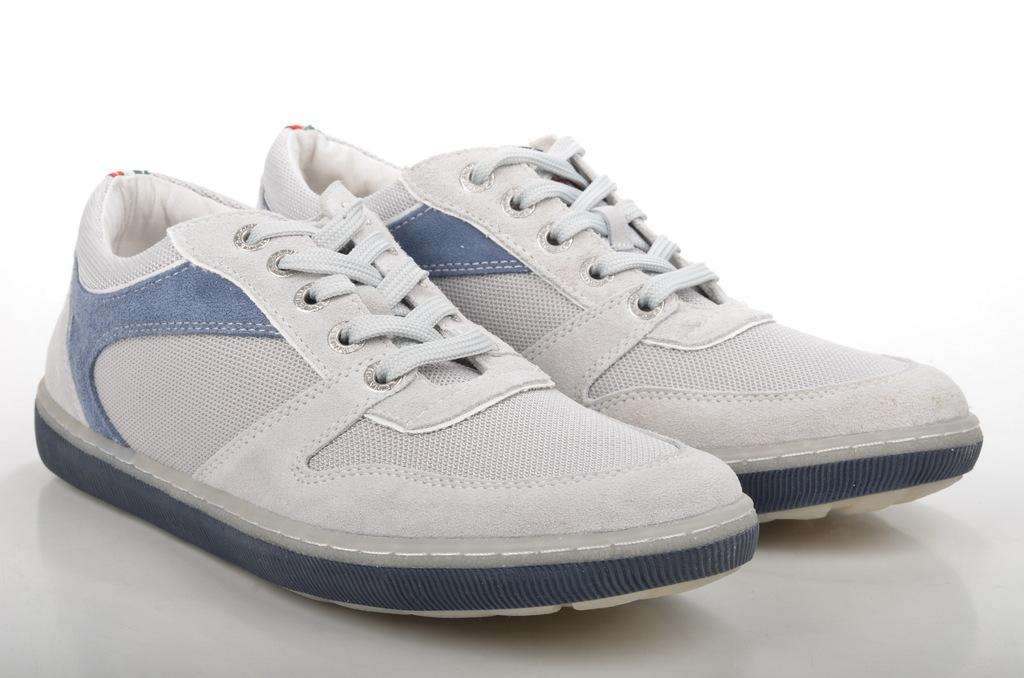What type of shoes are visible in the image? There are white shoes in the image. What color is the surface on which the shoes are placed? The shoes are on a white surface. What type of learning material can be seen near the shoes in the image? There is no learning material visible near the shoes in the image. 